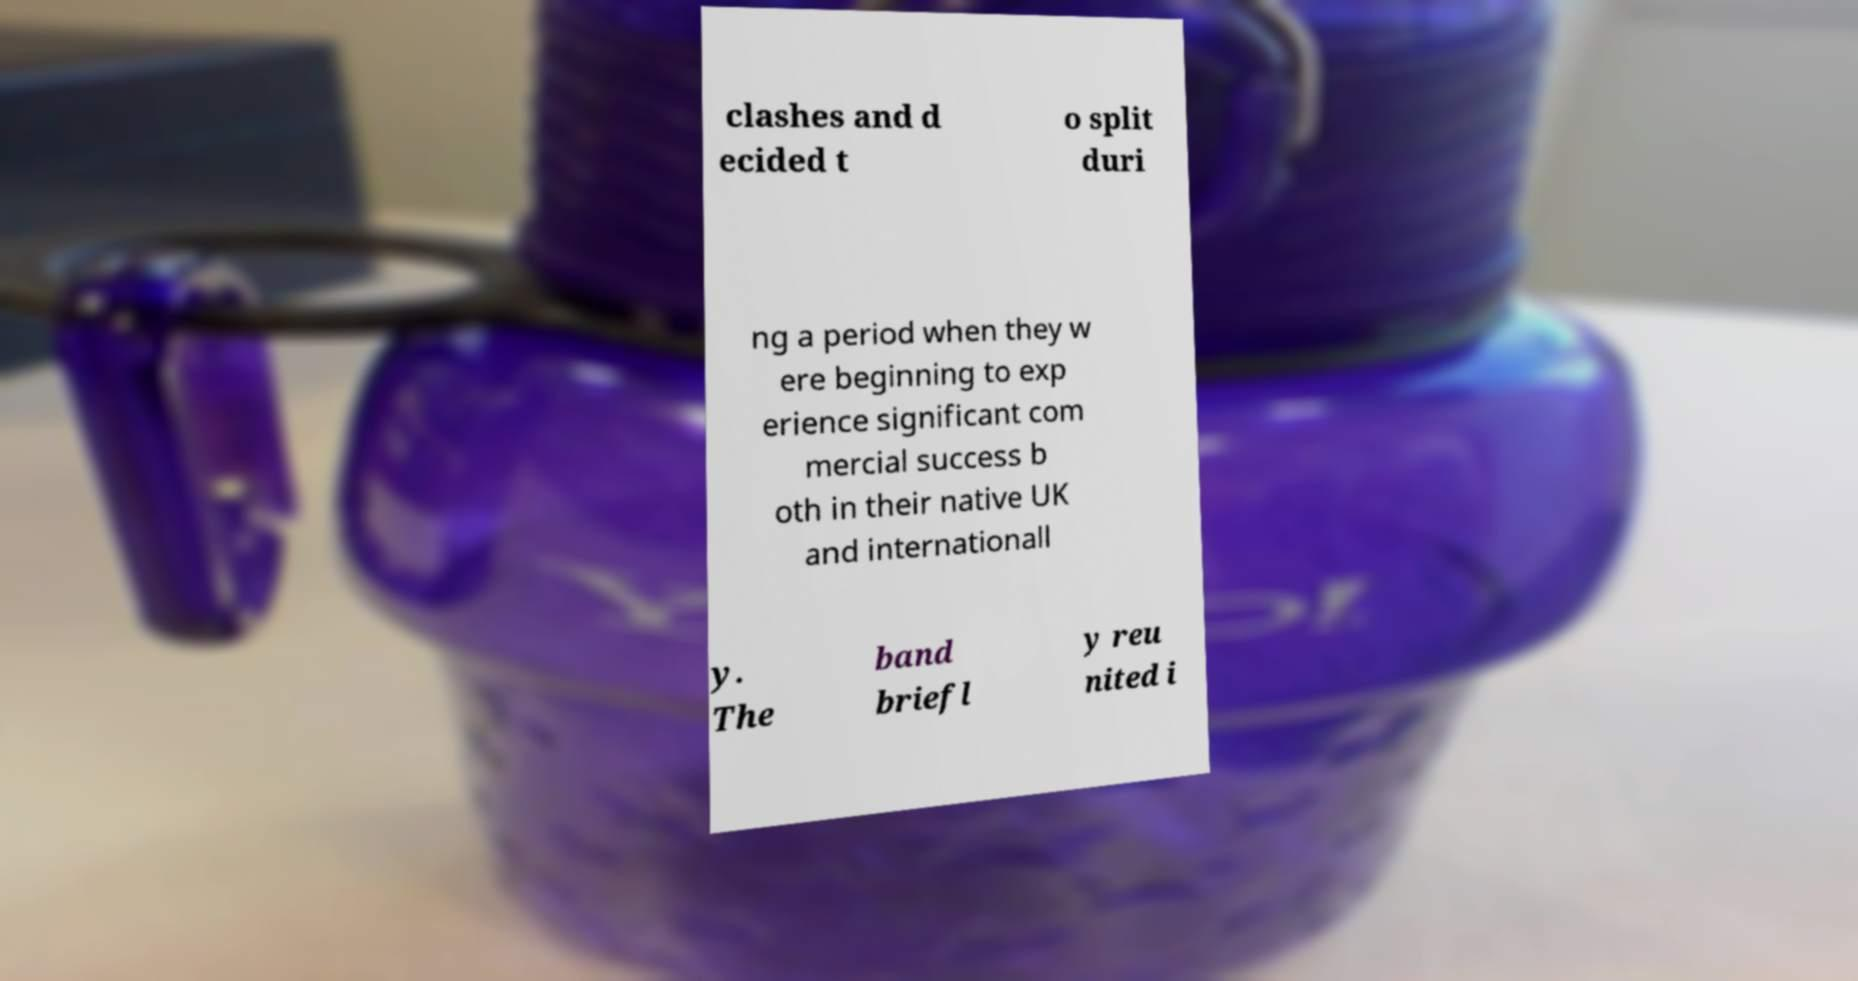What messages or text are displayed in this image? I need them in a readable, typed format. clashes and d ecided t o split duri ng a period when they w ere beginning to exp erience significant com mercial success b oth in their native UK and internationall y. The band briefl y reu nited i 